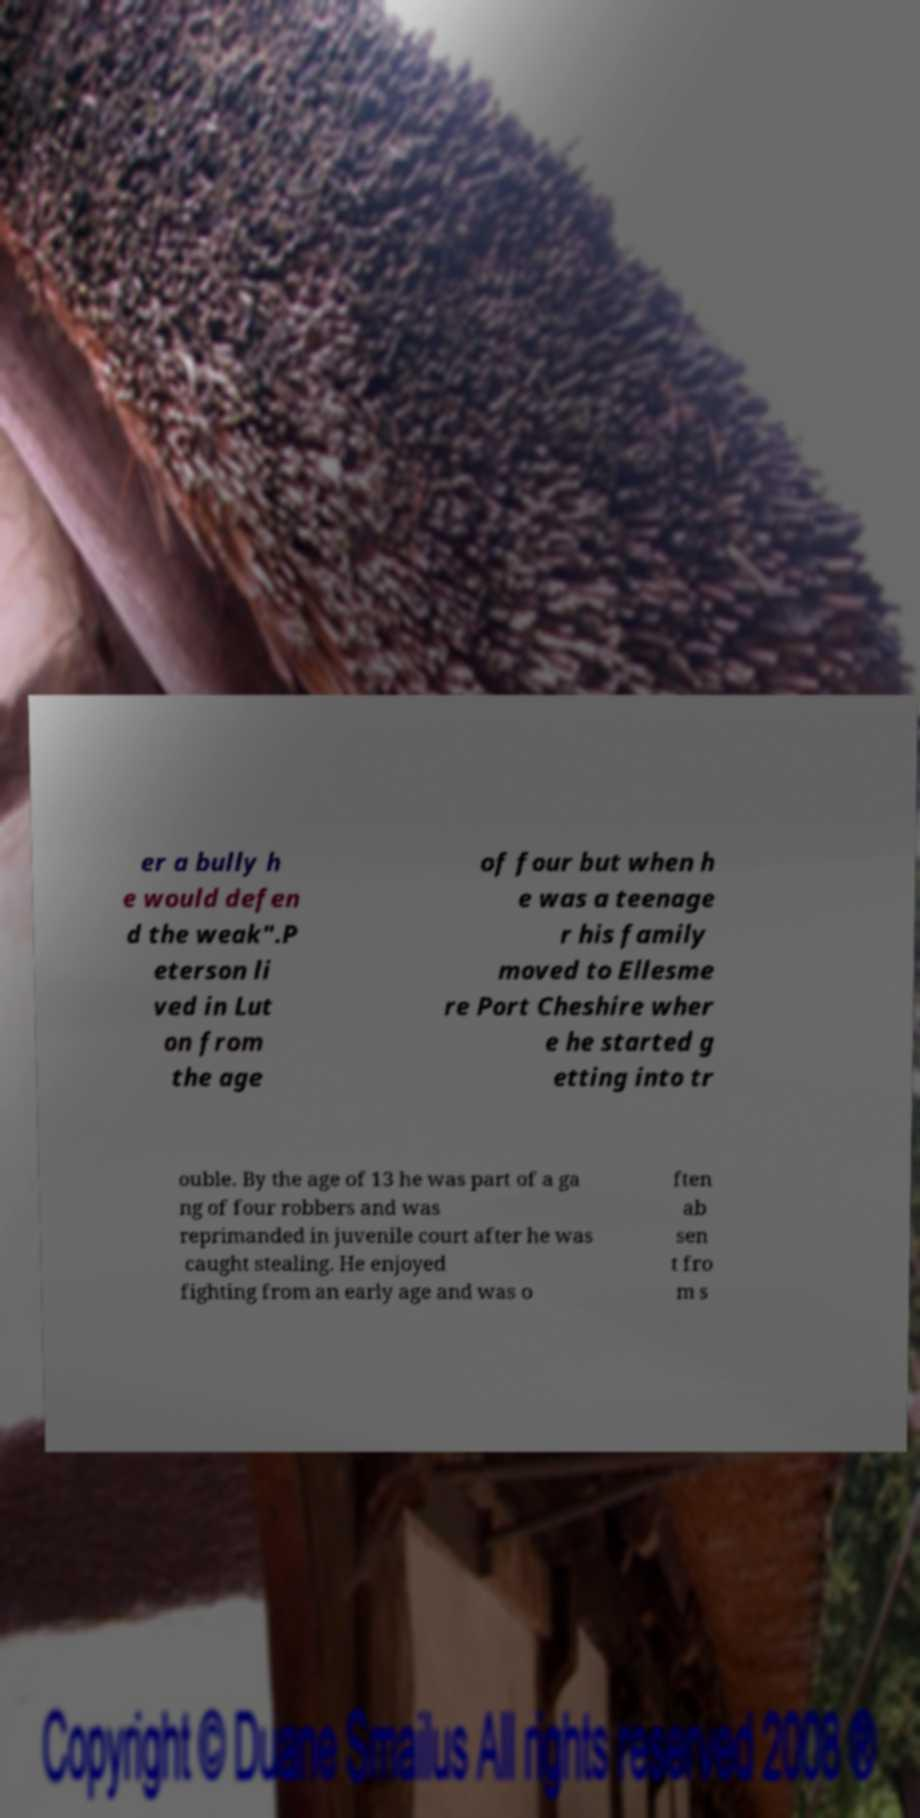Could you extract and type out the text from this image? er a bully h e would defen d the weak".P eterson li ved in Lut on from the age of four but when h e was a teenage r his family moved to Ellesme re Port Cheshire wher e he started g etting into tr ouble. By the age of 13 he was part of a ga ng of four robbers and was reprimanded in juvenile court after he was caught stealing. He enjoyed fighting from an early age and was o ften ab sen t fro m s 